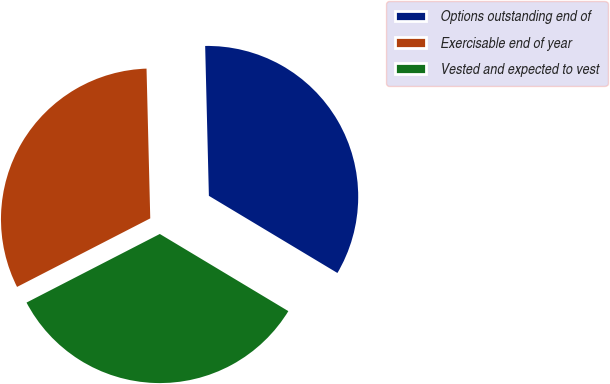<chart> <loc_0><loc_0><loc_500><loc_500><pie_chart><fcel>Options outstanding end of<fcel>Exercisable end of year<fcel>Vested and expected to vest<nl><fcel>34.0%<fcel>32.17%<fcel>33.83%<nl></chart> 